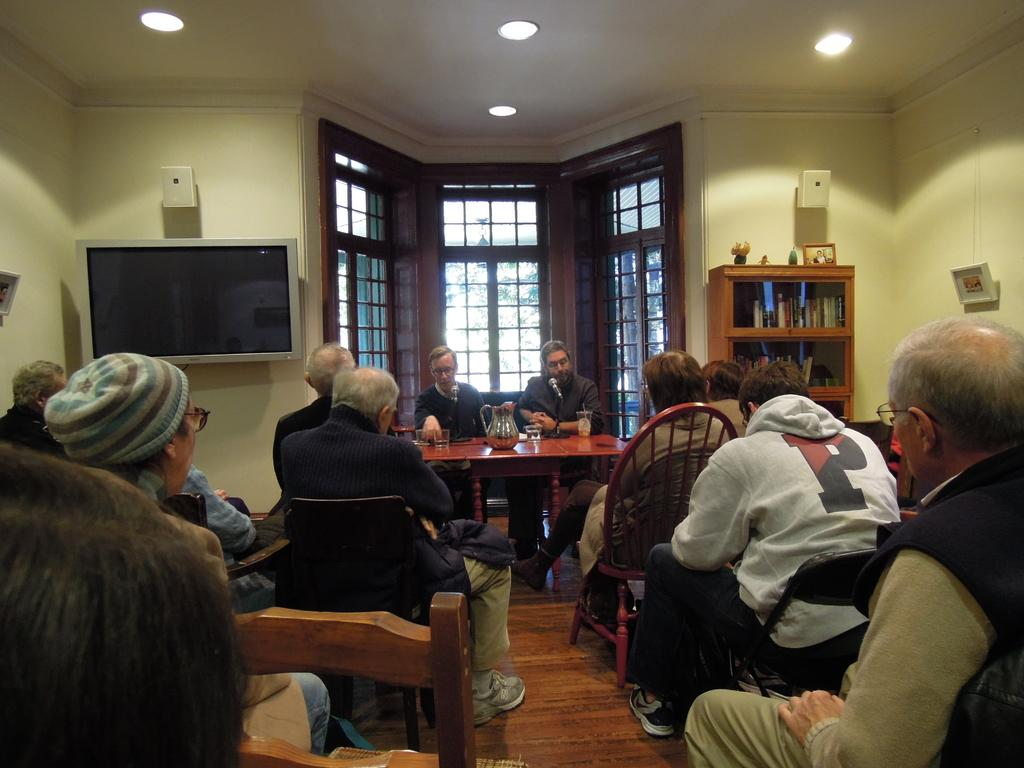What color is the wall that is visible in the image? There is a yellow color wall in the image. What can be seen through the window in the image? The image does not show what can be seen through the window. What electronic device is present in the image? There is a television in the image. What type of furniture is present in the image? There are shelves and chairs in the image. What is on the table in the image? There are glasses and a mug on the table. Is there a volleyball game being played in the image? No, there is no volleyball game present in the image. What type of root is growing on the table in the image? There are no roots present in the image; it features a table with glasses and a mug. 